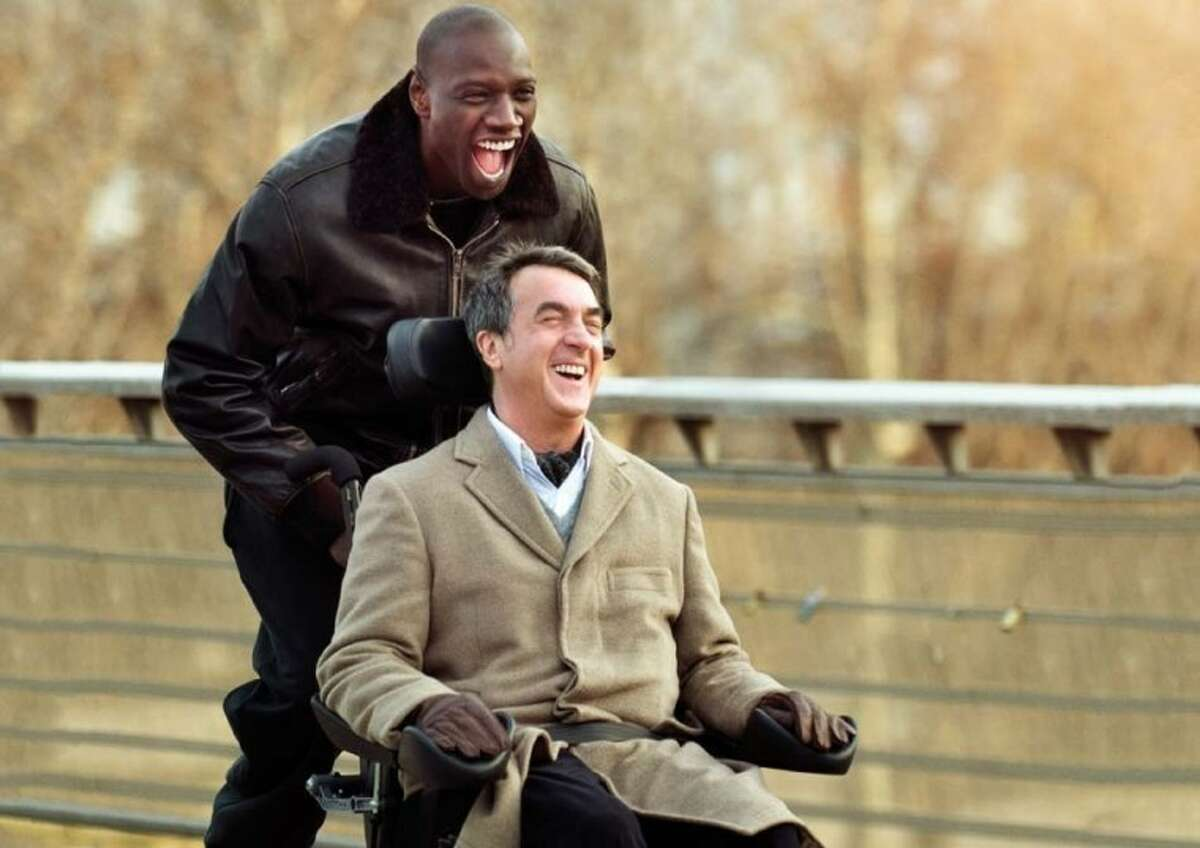Can you explain the significance of the location in the movie? The bridge setting is significant as it often represents transitions or crossings in film. Here, it symbolically reflects the overarching narrative of the movie, where two men from vastly different walks of life come together, bridging their differences through friendship and understanding. 